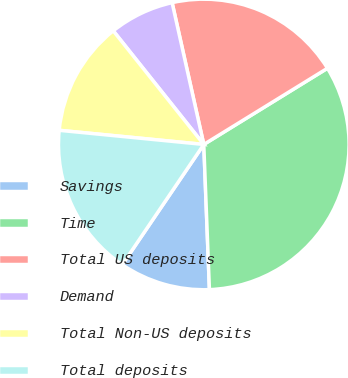Convert chart to OTSL. <chart><loc_0><loc_0><loc_500><loc_500><pie_chart><fcel>Savings<fcel>Time<fcel>Total US deposits<fcel>Demand<fcel>Total Non-US deposits<fcel>Total deposits<nl><fcel>10.1%<fcel>33.17%<fcel>19.71%<fcel>7.21%<fcel>12.74%<fcel>17.07%<nl></chart> 